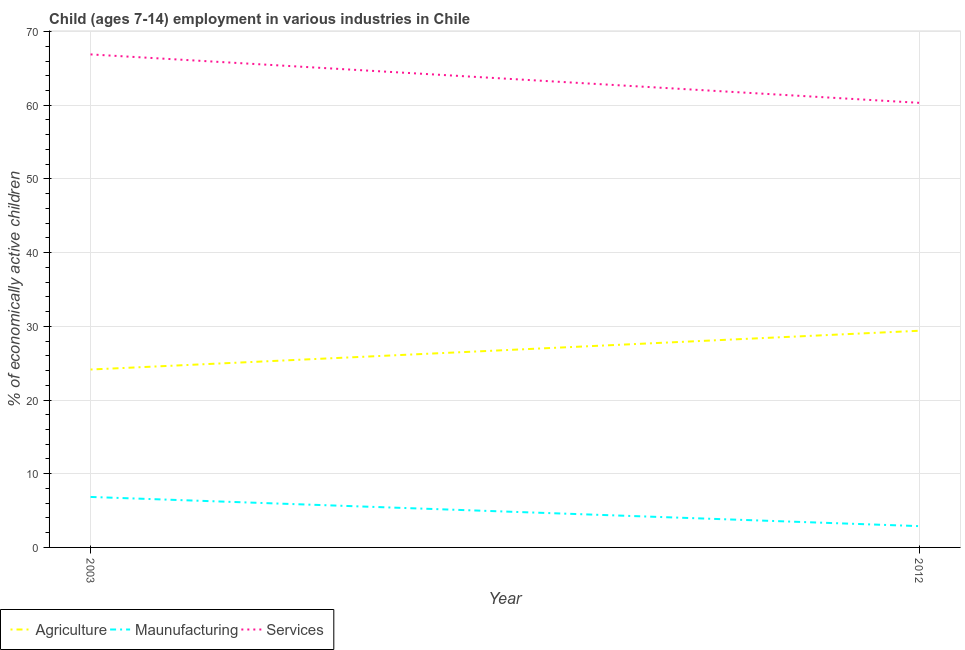How many different coloured lines are there?
Make the answer very short. 3. Is the number of lines equal to the number of legend labels?
Your answer should be compact. Yes. What is the percentage of economically active children in agriculture in 2003?
Ensure brevity in your answer.  24.14. Across all years, what is the maximum percentage of economically active children in services?
Offer a very short reply. 66.9. Across all years, what is the minimum percentage of economically active children in services?
Provide a succinct answer. 60.33. In which year was the percentage of economically active children in manufacturing minimum?
Your answer should be very brief. 2012. What is the total percentage of economically active children in manufacturing in the graph?
Offer a very short reply. 9.74. What is the difference between the percentage of economically active children in manufacturing in 2003 and that in 2012?
Ensure brevity in your answer.  3.96. What is the difference between the percentage of economically active children in manufacturing in 2012 and the percentage of economically active children in services in 2003?
Give a very brief answer. -64.01. What is the average percentage of economically active children in services per year?
Your answer should be very brief. 63.62. In the year 2003, what is the difference between the percentage of economically active children in agriculture and percentage of economically active children in services?
Offer a terse response. -42.76. What is the ratio of the percentage of economically active children in agriculture in 2003 to that in 2012?
Offer a very short reply. 0.82. Is the percentage of economically active children in agriculture in 2003 less than that in 2012?
Make the answer very short. Yes. Is it the case that in every year, the sum of the percentage of economically active children in agriculture and percentage of economically active children in manufacturing is greater than the percentage of economically active children in services?
Offer a very short reply. No. Does the percentage of economically active children in agriculture monotonically increase over the years?
Provide a succinct answer. Yes. Is the percentage of economically active children in manufacturing strictly greater than the percentage of economically active children in agriculture over the years?
Keep it short and to the point. No. How many lines are there?
Give a very brief answer. 3. How many years are there in the graph?
Ensure brevity in your answer.  2. Does the graph contain any zero values?
Your answer should be compact. No. How are the legend labels stacked?
Provide a short and direct response. Horizontal. What is the title of the graph?
Provide a short and direct response. Child (ages 7-14) employment in various industries in Chile. Does "Argument" appear as one of the legend labels in the graph?
Give a very brief answer. No. What is the label or title of the X-axis?
Give a very brief answer. Year. What is the label or title of the Y-axis?
Your answer should be very brief. % of economically active children. What is the % of economically active children of Agriculture in 2003?
Your answer should be very brief. 24.14. What is the % of economically active children in Maunufacturing in 2003?
Provide a short and direct response. 6.85. What is the % of economically active children in Services in 2003?
Make the answer very short. 66.9. What is the % of economically active children of Agriculture in 2012?
Your answer should be compact. 29.4. What is the % of economically active children in Maunufacturing in 2012?
Offer a very short reply. 2.89. What is the % of economically active children in Services in 2012?
Offer a very short reply. 60.33. Across all years, what is the maximum % of economically active children of Agriculture?
Your answer should be very brief. 29.4. Across all years, what is the maximum % of economically active children in Maunufacturing?
Give a very brief answer. 6.85. Across all years, what is the maximum % of economically active children of Services?
Your answer should be compact. 66.9. Across all years, what is the minimum % of economically active children in Agriculture?
Provide a short and direct response. 24.14. Across all years, what is the minimum % of economically active children of Maunufacturing?
Make the answer very short. 2.89. Across all years, what is the minimum % of economically active children of Services?
Your response must be concise. 60.33. What is the total % of economically active children in Agriculture in the graph?
Offer a very short reply. 53.54. What is the total % of economically active children of Maunufacturing in the graph?
Ensure brevity in your answer.  9.74. What is the total % of economically active children in Services in the graph?
Your response must be concise. 127.23. What is the difference between the % of economically active children of Agriculture in 2003 and that in 2012?
Offer a terse response. -5.26. What is the difference between the % of economically active children of Maunufacturing in 2003 and that in 2012?
Offer a terse response. 3.96. What is the difference between the % of economically active children of Services in 2003 and that in 2012?
Provide a succinct answer. 6.57. What is the difference between the % of economically active children of Agriculture in 2003 and the % of economically active children of Maunufacturing in 2012?
Your answer should be very brief. 21.25. What is the difference between the % of economically active children in Agriculture in 2003 and the % of economically active children in Services in 2012?
Provide a succinct answer. -36.19. What is the difference between the % of economically active children in Maunufacturing in 2003 and the % of economically active children in Services in 2012?
Give a very brief answer. -53.48. What is the average % of economically active children of Agriculture per year?
Keep it short and to the point. 26.77. What is the average % of economically active children of Maunufacturing per year?
Your response must be concise. 4.87. What is the average % of economically active children in Services per year?
Offer a terse response. 63.62. In the year 2003, what is the difference between the % of economically active children of Agriculture and % of economically active children of Maunufacturing?
Ensure brevity in your answer.  17.29. In the year 2003, what is the difference between the % of economically active children of Agriculture and % of economically active children of Services?
Ensure brevity in your answer.  -42.76. In the year 2003, what is the difference between the % of economically active children in Maunufacturing and % of economically active children in Services?
Ensure brevity in your answer.  -60.05. In the year 2012, what is the difference between the % of economically active children of Agriculture and % of economically active children of Maunufacturing?
Ensure brevity in your answer.  26.51. In the year 2012, what is the difference between the % of economically active children of Agriculture and % of economically active children of Services?
Offer a terse response. -30.93. In the year 2012, what is the difference between the % of economically active children in Maunufacturing and % of economically active children in Services?
Ensure brevity in your answer.  -57.44. What is the ratio of the % of economically active children in Agriculture in 2003 to that in 2012?
Provide a succinct answer. 0.82. What is the ratio of the % of economically active children in Maunufacturing in 2003 to that in 2012?
Your answer should be very brief. 2.37. What is the ratio of the % of economically active children of Services in 2003 to that in 2012?
Keep it short and to the point. 1.11. What is the difference between the highest and the second highest % of economically active children of Agriculture?
Your response must be concise. 5.26. What is the difference between the highest and the second highest % of economically active children of Maunufacturing?
Provide a short and direct response. 3.96. What is the difference between the highest and the second highest % of economically active children in Services?
Your response must be concise. 6.57. What is the difference between the highest and the lowest % of economically active children in Agriculture?
Keep it short and to the point. 5.26. What is the difference between the highest and the lowest % of economically active children of Maunufacturing?
Offer a very short reply. 3.96. What is the difference between the highest and the lowest % of economically active children of Services?
Provide a short and direct response. 6.57. 